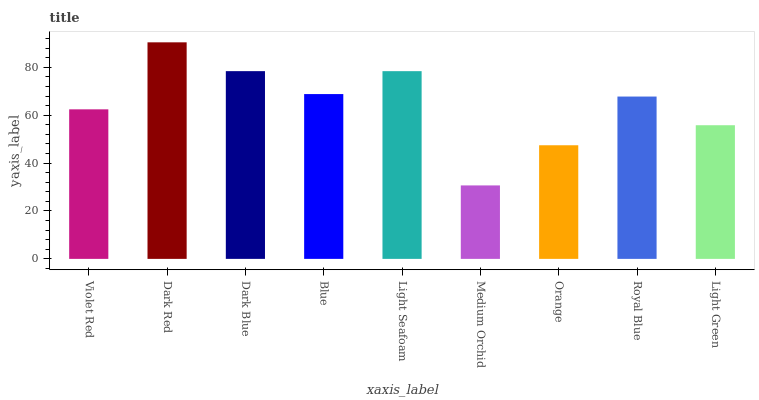Is Medium Orchid the minimum?
Answer yes or no. Yes. Is Dark Red the maximum?
Answer yes or no. Yes. Is Dark Blue the minimum?
Answer yes or no. No. Is Dark Blue the maximum?
Answer yes or no. No. Is Dark Red greater than Dark Blue?
Answer yes or no. Yes. Is Dark Blue less than Dark Red?
Answer yes or no. Yes. Is Dark Blue greater than Dark Red?
Answer yes or no. No. Is Dark Red less than Dark Blue?
Answer yes or no. No. Is Royal Blue the high median?
Answer yes or no. Yes. Is Royal Blue the low median?
Answer yes or no. Yes. Is Dark Red the high median?
Answer yes or no. No. Is Blue the low median?
Answer yes or no. No. 